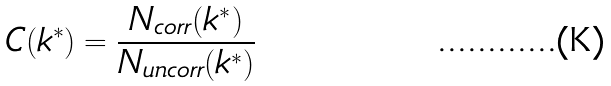Convert formula to latex. <formula><loc_0><loc_0><loc_500><loc_500>C ( k ^ { * } ) = \frac { N _ { c o r r } ( k ^ { * } ) } { N _ { u n c o r r } ( k ^ { * } ) }</formula> 